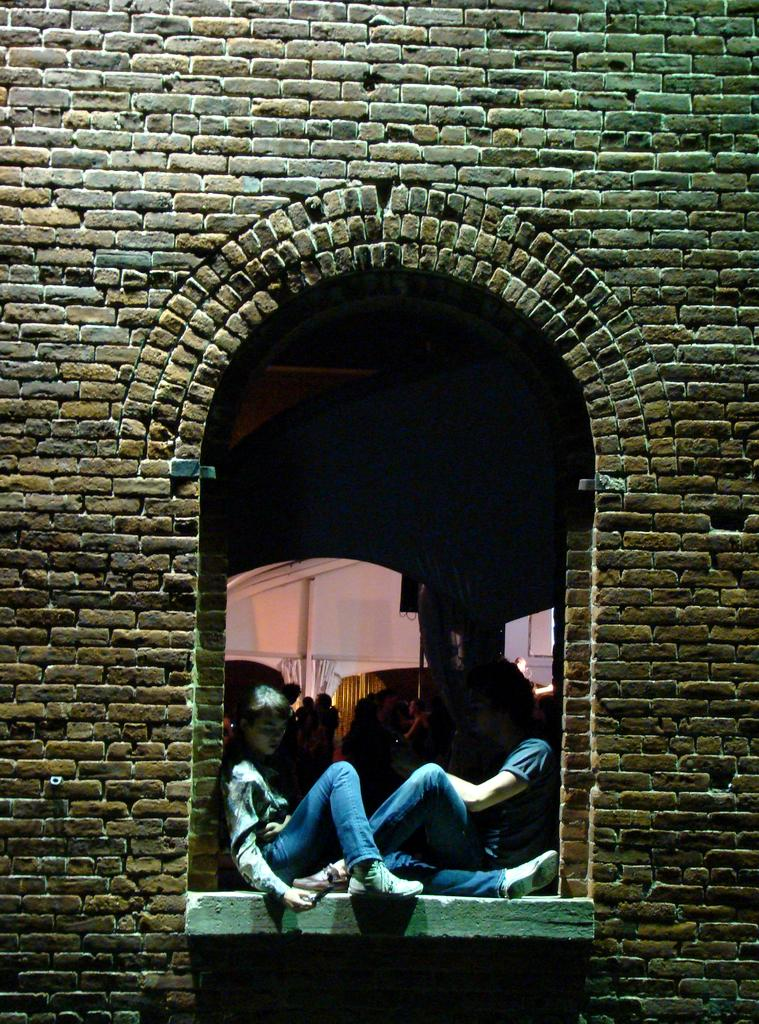What are the people in the image doing? The people in the image are sitting. Are there any people in the background of the image? Yes, some people are standing in the background of the image. What else can be seen in the image besides people? There are objects visible in the image. What is located in the foreground of the image? There is a wall in the foreground of the image. What type of animals can be seen at the zoo in the image? There is no zoo present in the image, so it is not possible to determine what animals might be seen there. 